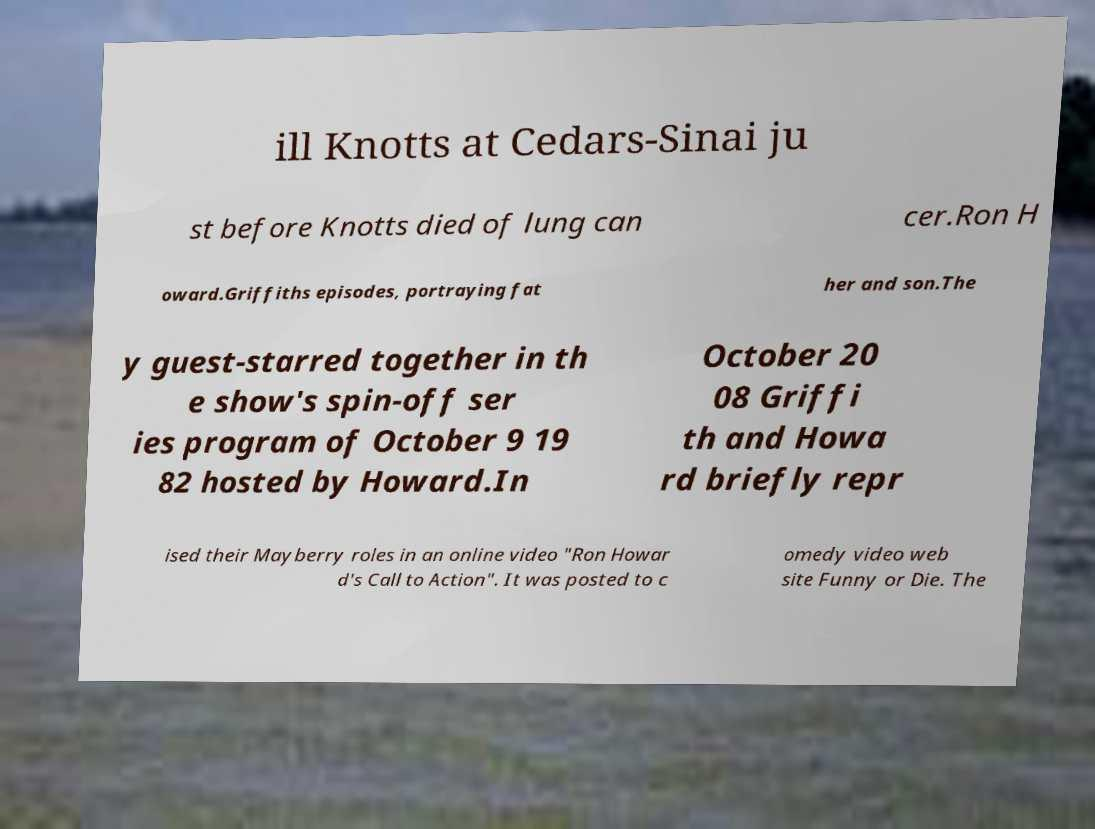Please read and relay the text visible in this image. What does it say? ill Knotts at Cedars-Sinai ju st before Knotts died of lung can cer.Ron H oward.Griffiths episodes, portraying fat her and son.The y guest-starred together in th e show's spin-off ser ies program of October 9 19 82 hosted by Howard.In October 20 08 Griffi th and Howa rd briefly repr ised their Mayberry roles in an online video "Ron Howar d's Call to Action". It was posted to c omedy video web site Funny or Die. The 